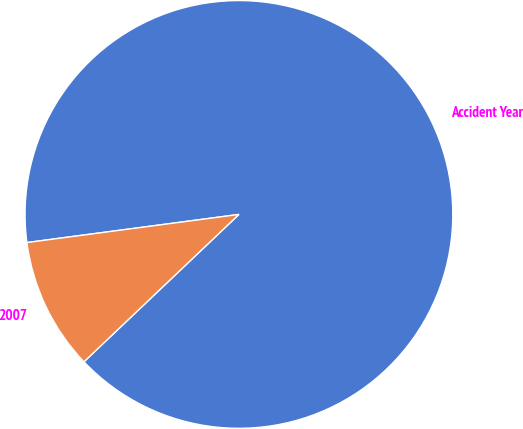<chart> <loc_0><loc_0><loc_500><loc_500><pie_chart><fcel>Accident Year<fcel>2007<nl><fcel>90.0%<fcel>10.0%<nl></chart> 